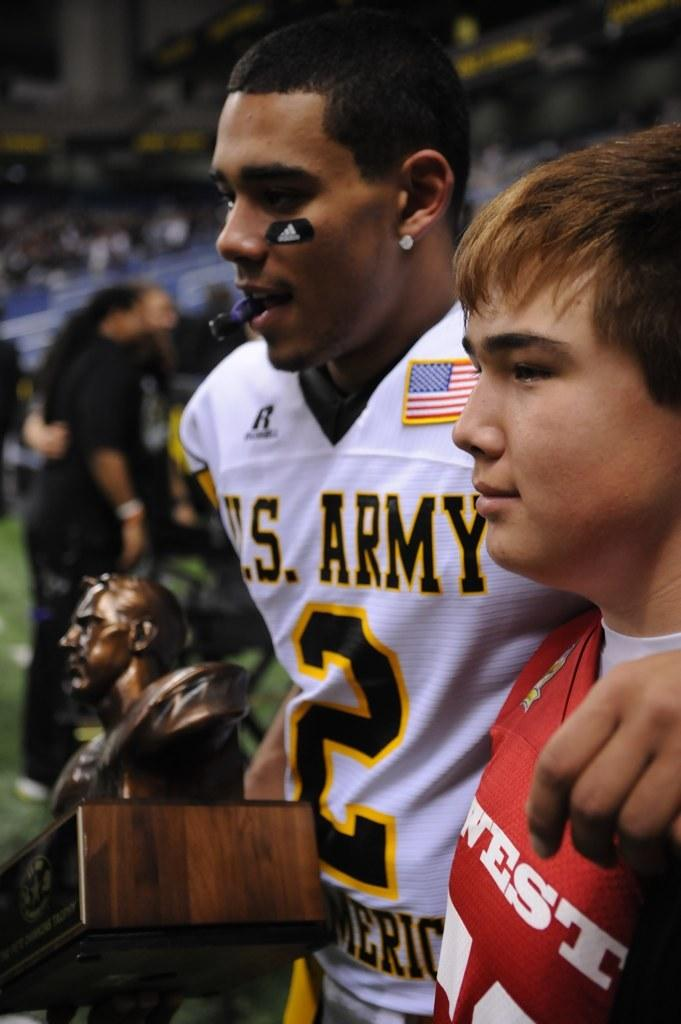<image>
Offer a succinct explanation of the picture presented. A football player for the U.S. Army stands on the field with his arm around a boy. 